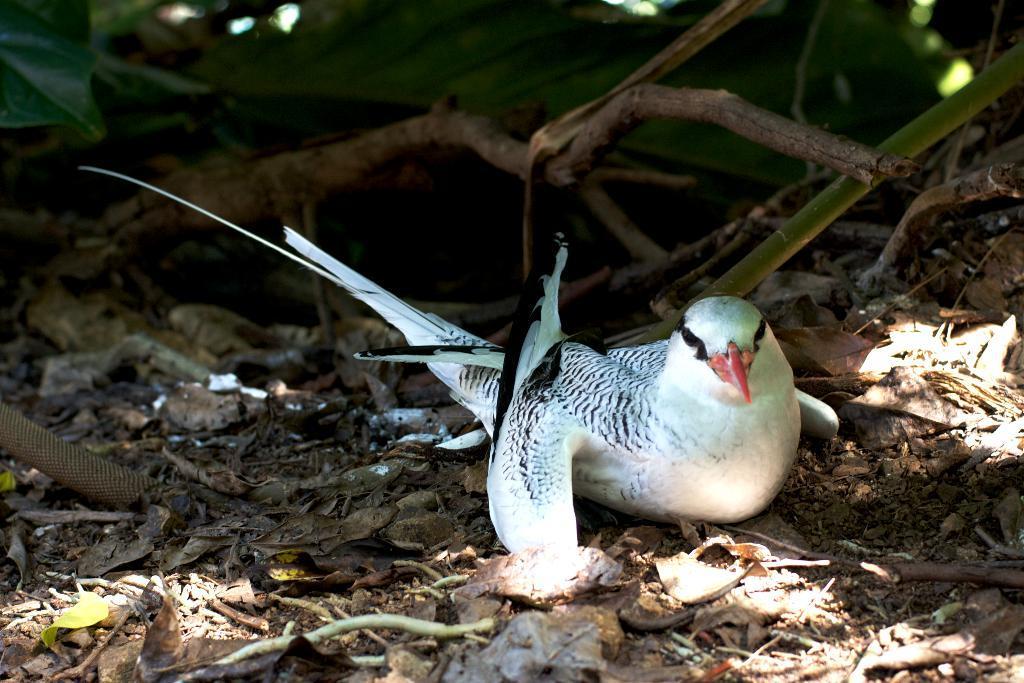In one or two sentences, can you explain what this image depicts? In this image I can see a bird is sitting on the ground, at the top there are dried sticks. In the background there are green leaves, on the right side it looks like a stem. 